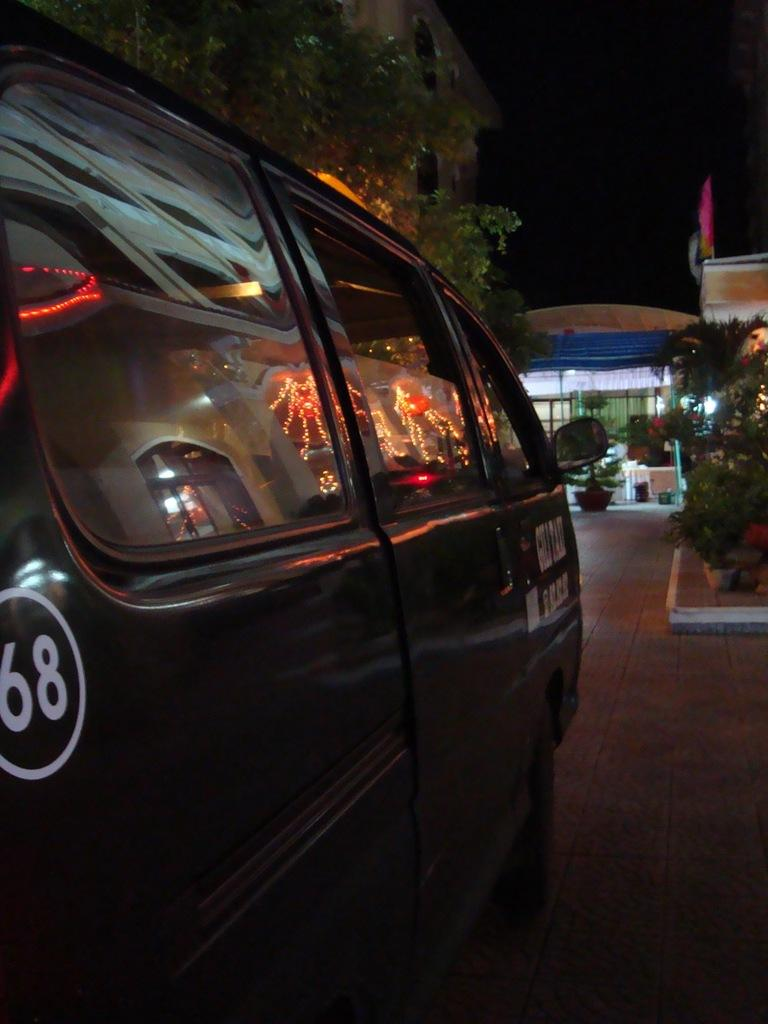What is on the path in the image? There is a vehicle on the path in the image. What can be seen behind the vehicle? There are trees, plants, and a house behind the vehicle. What is the background behind the house? The background behind the house is dark. Where is the desk located in the image? There is no desk present in the image. What type of slip can be seen on the vehicle in the image? There is no slip visible on the vehicle in the image. 